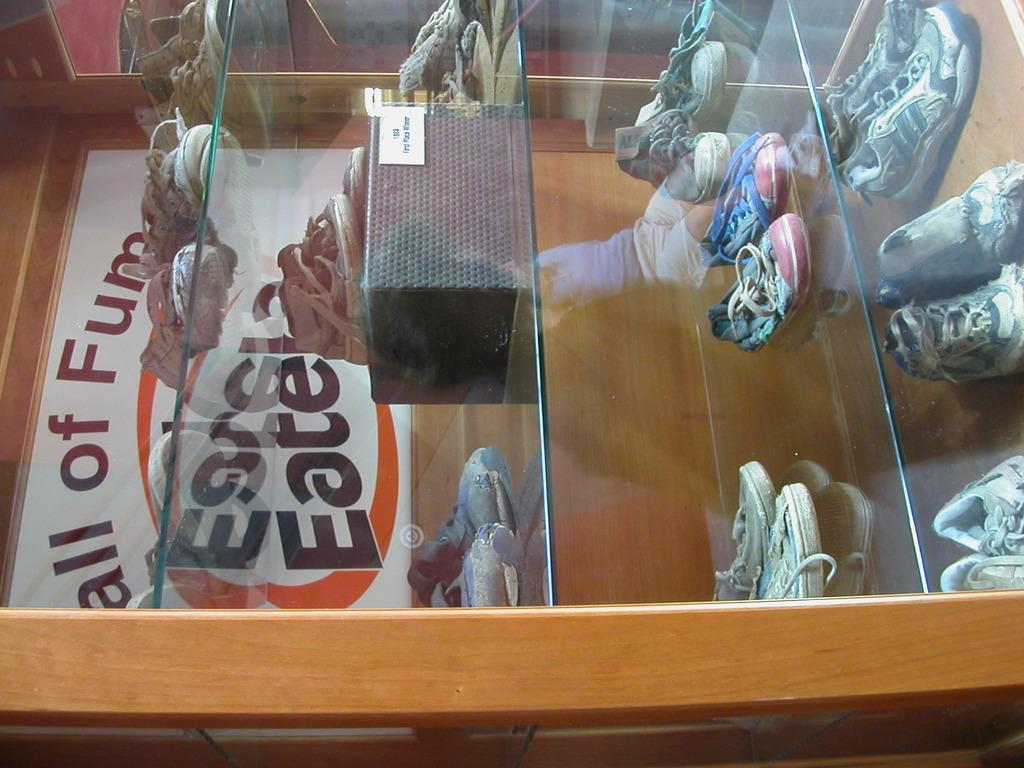What objects are in the image? There are shoes in the image. Where are the shoes placed? The shoes are on glass shelves. What can be seen on the left side of the image? There is a board on the left side of the image. What type of pear is being discussed by the committee in the image? There is no pear or committee present in the image; it features shoes on glass shelves and a board on the left side. 